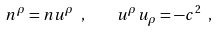Convert formula to latex. <formula><loc_0><loc_0><loc_500><loc_500>n ^ { \rho } = n u ^ { \rho } \ , \quad u ^ { \rho } u _ { \rho } = - c ^ { 2 } \ ,</formula> 